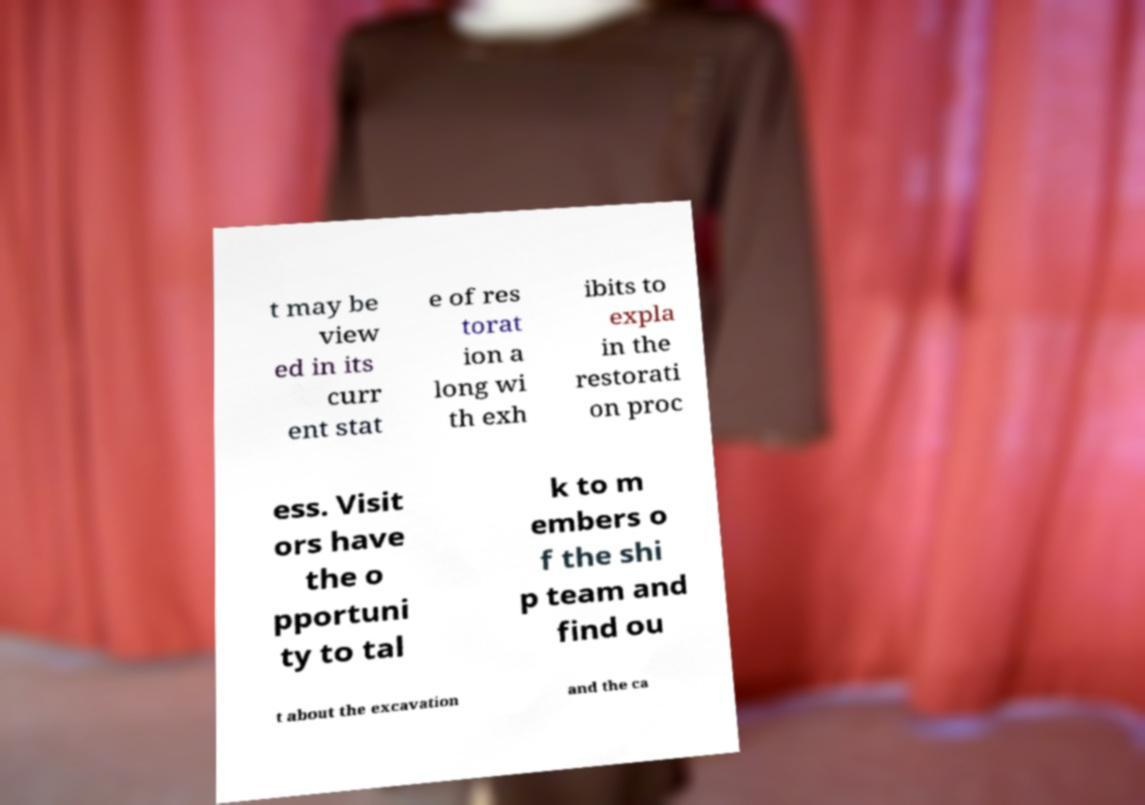I need the written content from this picture converted into text. Can you do that? t may be view ed in its curr ent stat e of res torat ion a long wi th exh ibits to expla in the restorati on proc ess. Visit ors have the o pportuni ty to tal k to m embers o f the shi p team and find ou t about the excavation and the ca 